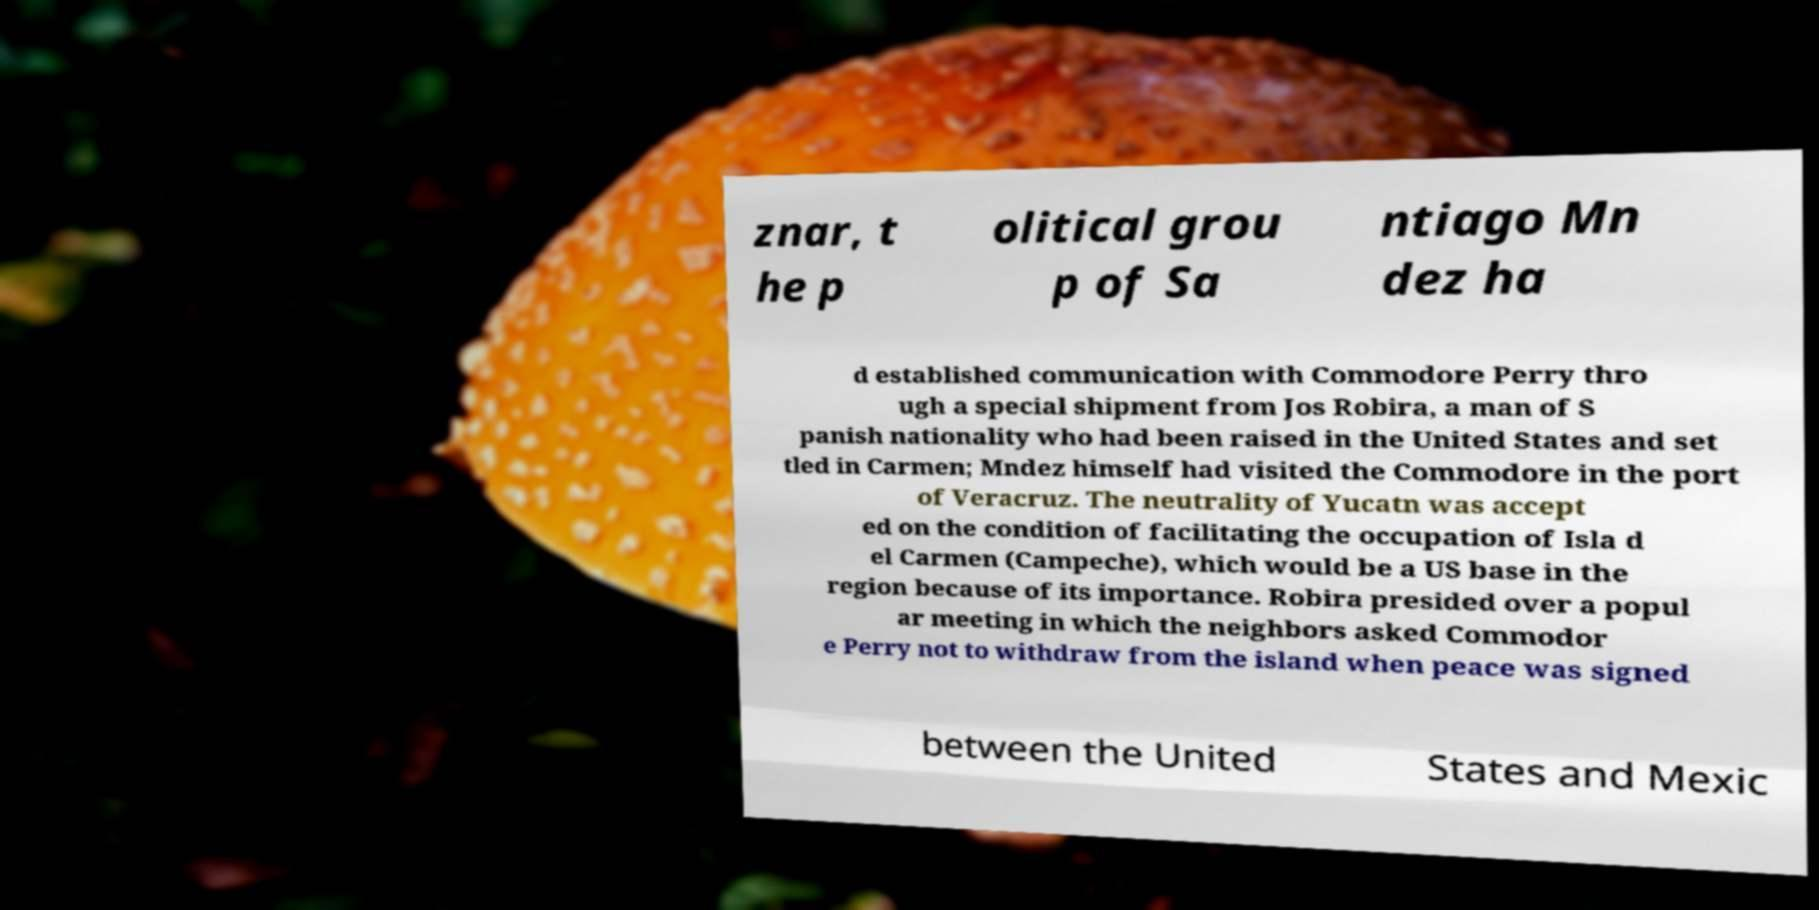I need the written content from this picture converted into text. Can you do that? znar, t he p olitical grou p of Sa ntiago Mn dez ha d established communication with Commodore Perry thro ugh a special shipment from Jos Robira, a man of S panish nationality who had been raised in the United States and set tled in Carmen; Mndez himself had visited the Commodore in the port of Veracruz. The neutrality of Yucatn was accept ed on the condition of facilitating the occupation of Isla d el Carmen (Campeche), which would be a US base in the region because of its importance. Robira presided over a popul ar meeting in which the neighbors asked Commodor e Perry not to withdraw from the island when peace was signed between the United States and Mexic 